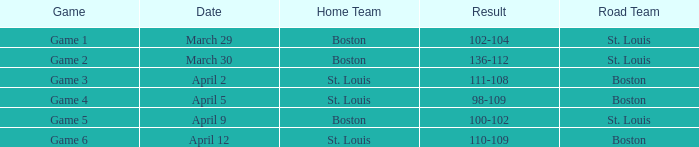What is the Game number on March 30? Game 2. 